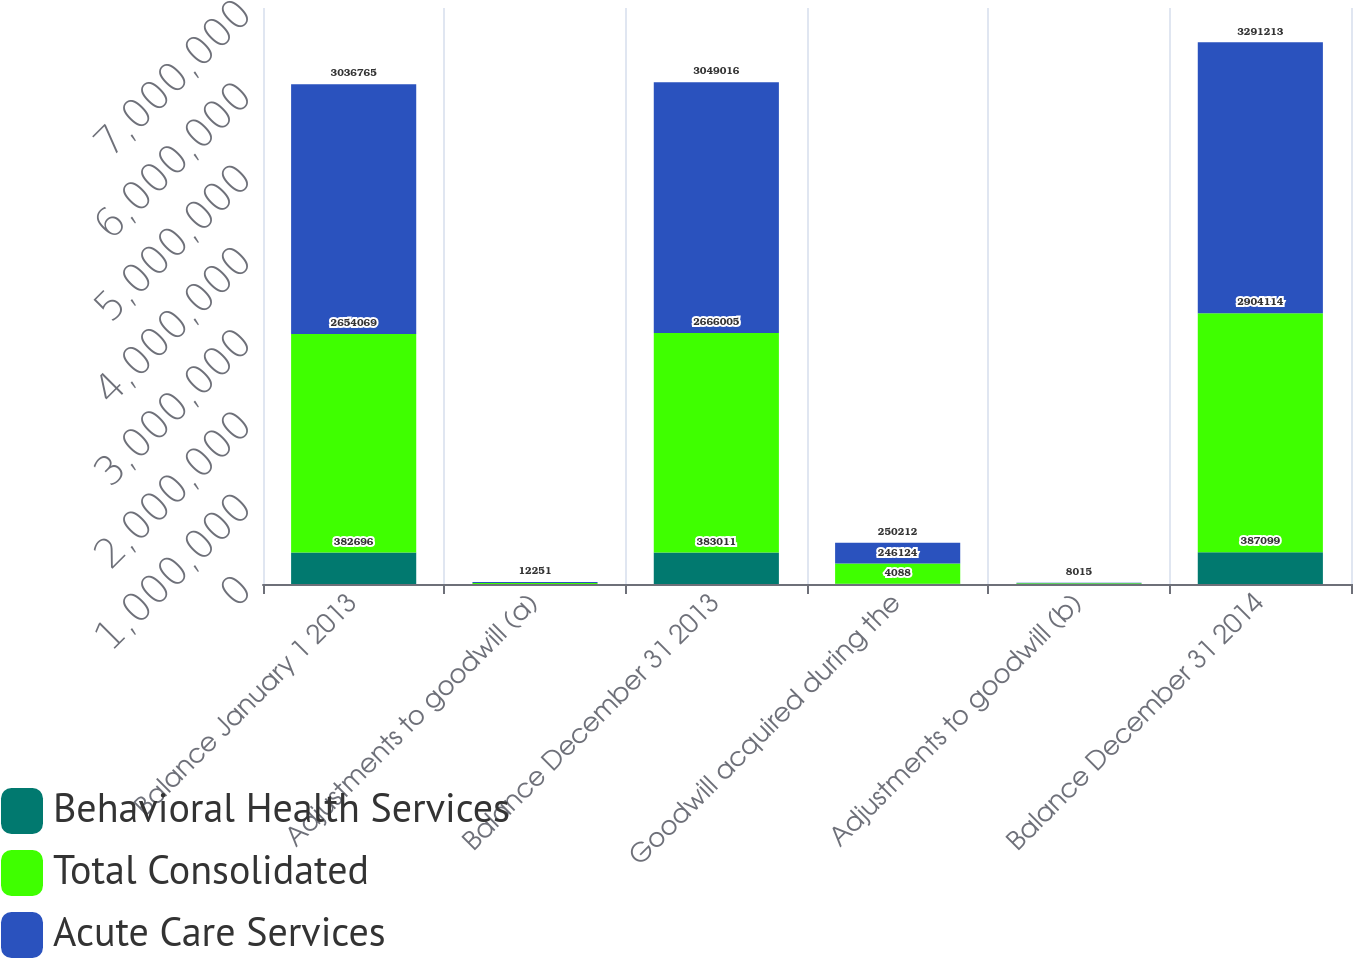Convert chart. <chart><loc_0><loc_0><loc_500><loc_500><stacked_bar_chart><ecel><fcel>Balance January 1 2013<fcel>Adjustments to goodwill (a)<fcel>Balance December 31 2013<fcel>Goodwill acquired during the<fcel>Adjustments to goodwill (b)<fcel>Balance December 31 2014<nl><fcel>Behavioral Health Services<fcel>382696<fcel>315<fcel>383011<fcel>4088<fcel>0<fcel>387099<nl><fcel>Total Consolidated<fcel>2.65407e+06<fcel>11936<fcel>2.666e+06<fcel>246124<fcel>8015<fcel>2.90411e+06<nl><fcel>Acute Care Services<fcel>3.03676e+06<fcel>12251<fcel>3.04902e+06<fcel>250212<fcel>8015<fcel>3.29121e+06<nl></chart> 